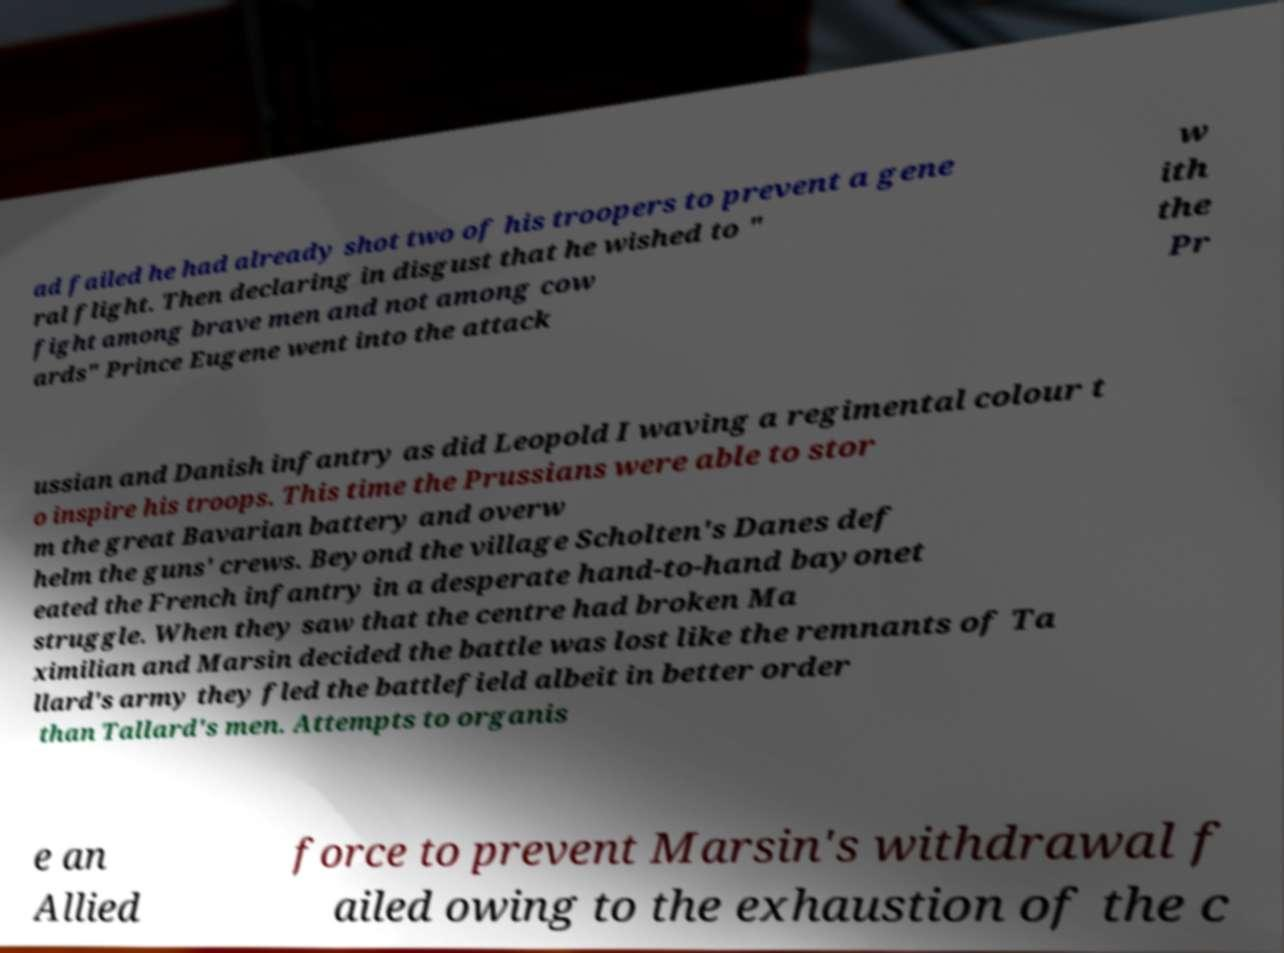Could you assist in decoding the text presented in this image and type it out clearly? ad failed he had already shot two of his troopers to prevent a gene ral flight. Then declaring in disgust that he wished to " fight among brave men and not among cow ards" Prince Eugene went into the attack w ith the Pr ussian and Danish infantry as did Leopold I waving a regimental colour t o inspire his troops. This time the Prussians were able to stor m the great Bavarian battery and overw helm the guns' crews. Beyond the village Scholten's Danes def eated the French infantry in a desperate hand-to-hand bayonet struggle. When they saw that the centre had broken Ma ximilian and Marsin decided the battle was lost like the remnants of Ta llard's army they fled the battlefield albeit in better order than Tallard's men. Attempts to organis e an Allied force to prevent Marsin's withdrawal f ailed owing to the exhaustion of the c 